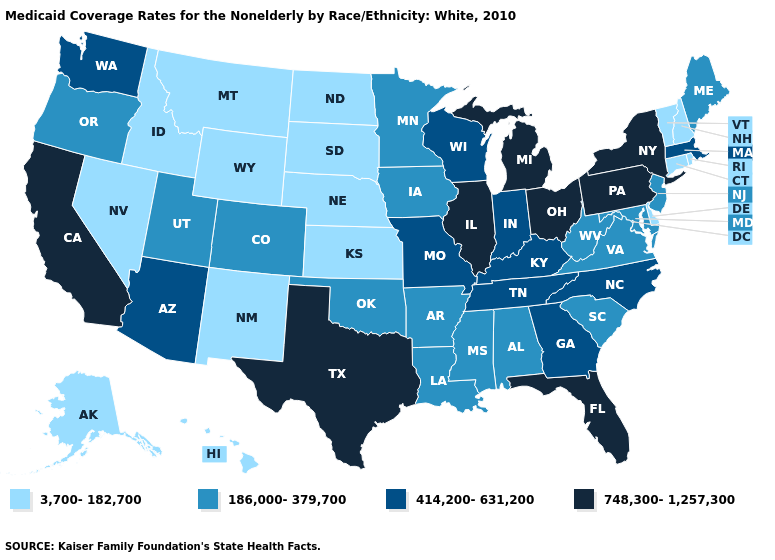Which states have the highest value in the USA?
Quick response, please. California, Florida, Illinois, Michigan, New York, Ohio, Pennsylvania, Texas. Does Oregon have a lower value than South Dakota?
Quick response, please. No. Does Arizona have the lowest value in the USA?
Short answer required. No. Name the states that have a value in the range 3,700-182,700?
Quick response, please. Alaska, Connecticut, Delaware, Hawaii, Idaho, Kansas, Montana, Nebraska, Nevada, New Hampshire, New Mexico, North Dakota, Rhode Island, South Dakota, Vermont, Wyoming. What is the value of Mississippi?
Answer briefly. 186,000-379,700. Among the states that border New Mexico , does Arizona have the lowest value?
Quick response, please. No. Among the states that border Connecticut , which have the highest value?
Be succinct. New York. Among the states that border Missouri , which have the lowest value?
Write a very short answer. Kansas, Nebraska. Does Texas have the highest value in the USA?
Be succinct. Yes. Among the states that border Connecticut , which have the highest value?
Keep it brief. New York. Does Georgia have a lower value than California?
Quick response, please. Yes. What is the value of Missouri?
Keep it brief. 414,200-631,200. Name the states that have a value in the range 3,700-182,700?
Concise answer only. Alaska, Connecticut, Delaware, Hawaii, Idaho, Kansas, Montana, Nebraska, Nevada, New Hampshire, New Mexico, North Dakota, Rhode Island, South Dakota, Vermont, Wyoming. Name the states that have a value in the range 186,000-379,700?
Be succinct. Alabama, Arkansas, Colorado, Iowa, Louisiana, Maine, Maryland, Minnesota, Mississippi, New Jersey, Oklahoma, Oregon, South Carolina, Utah, Virginia, West Virginia. How many symbols are there in the legend?
Be succinct. 4. 